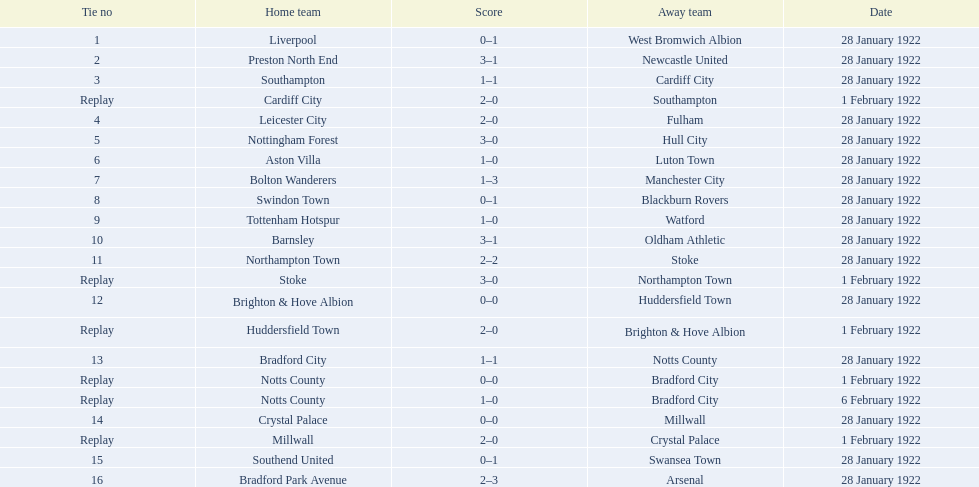How many games had four total points scored or more? 5. 